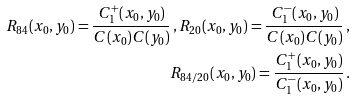Convert formula to latex. <formula><loc_0><loc_0><loc_500><loc_500>R _ { 8 4 } ( x _ { 0 } , y _ { 0 } ) = \frac { C _ { 1 } ^ { + } ( x _ { 0 } , y _ { 0 } ) } { C ( x _ { 0 } ) C ( y _ { 0 } ) } \, , R _ { 2 0 } ( x _ { 0 } , y _ { 0 } ) = \frac { C _ { 1 } ^ { - } ( x _ { 0 } , y _ { 0 } ) } { C ( x _ { 0 } ) C ( y _ { 0 } ) } \, , \\ R _ { 8 4 / 2 0 } ( x _ { 0 } , y _ { 0 } ) = \frac { C _ { 1 } ^ { + } ( x _ { 0 } , y _ { 0 } ) } { C _ { 1 } ^ { - } ( x _ { 0 } , y _ { 0 } ) } \, .</formula> 